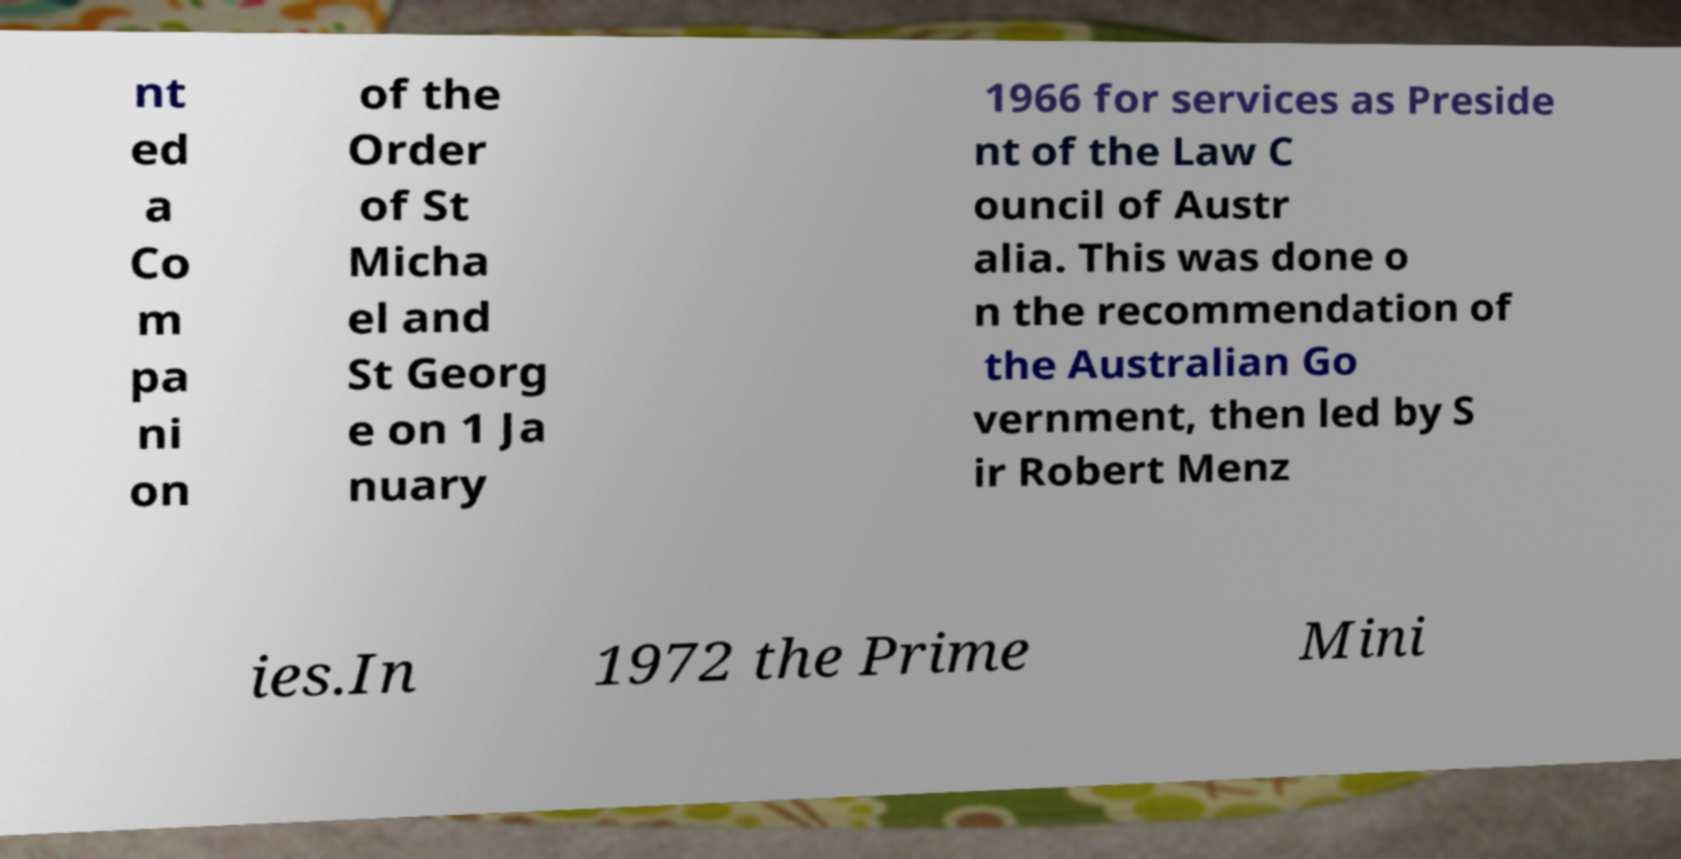For documentation purposes, I need the text within this image transcribed. Could you provide that? nt ed a Co m pa ni on of the Order of St Micha el and St Georg e on 1 Ja nuary 1966 for services as Preside nt of the Law C ouncil of Austr alia. This was done o n the recommendation of the Australian Go vernment, then led by S ir Robert Menz ies.In 1972 the Prime Mini 